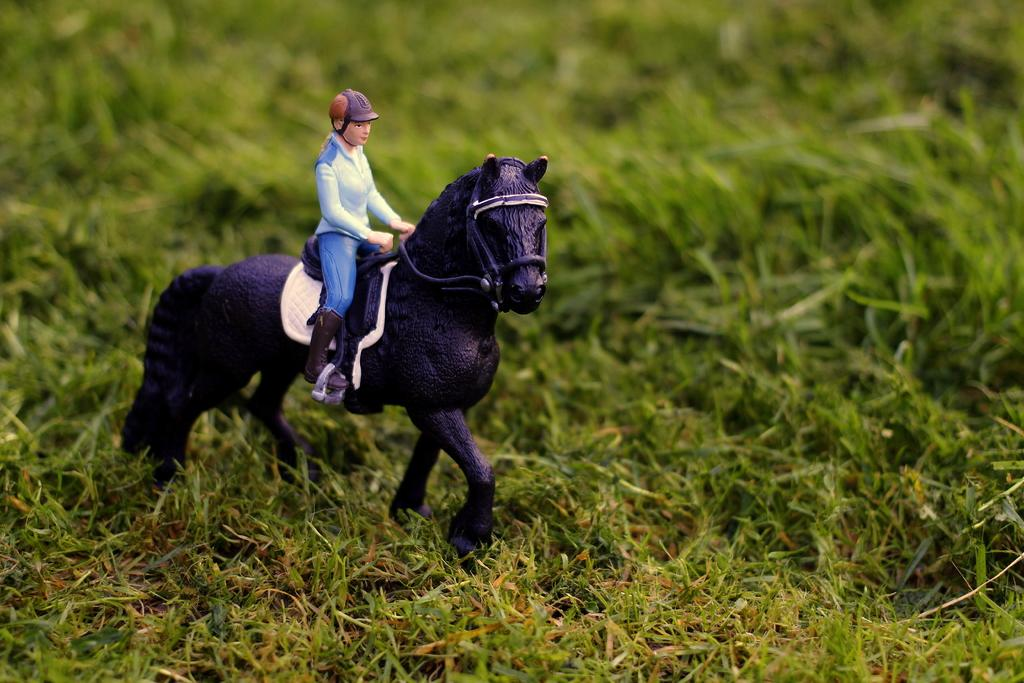What type of toys are present in the image? There is a toy of a person and a toy of a horse in the image. Where are the toys located? Both toys are on the grass. What color is the sweater worn by the person toy in the image? There is no sweater present in the image, as the toy is not wearing any clothing. 